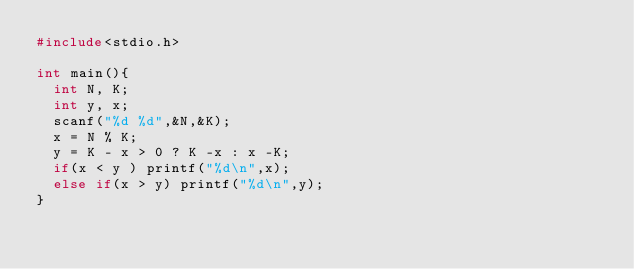<code> <loc_0><loc_0><loc_500><loc_500><_C_>#include<stdio.h>

int main(){
  int N, K;
  int y, x;
  scanf("%d %d",&N,&K);
  x = N % K;
  y = K - x > 0 ? K -x : x -K;
  if(x < y ) printf("%d\n",x);
  else if(x > y) printf("%d\n",y);
}
</code> 